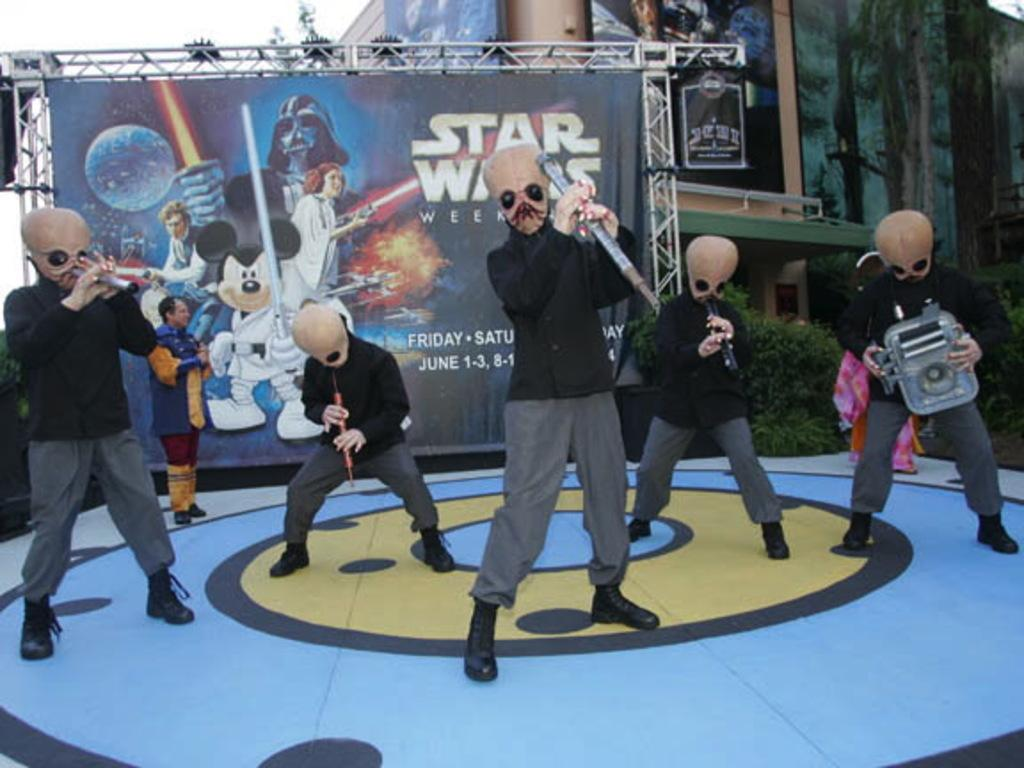How many people are in the image? There is a group of people in the image. What are the people holding in the image? The people are holding objects. What can be seen in the background of the image? There is a banner, posters, hoardings, a building, a wall, rods, plants, and the sky visible in the background of the image. What month is it in the image? The month cannot be determined from the image, as there is no information about the date or time of year. How many women are in the image? The gender of the people in the image cannot be determined from the image, as there is no information about their gender. 